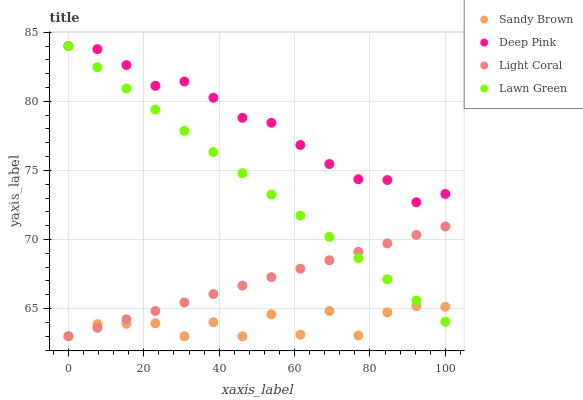Does Sandy Brown have the minimum area under the curve?
Answer yes or no. Yes. Does Deep Pink have the maximum area under the curve?
Answer yes or no. Yes. Does Lawn Green have the minimum area under the curve?
Answer yes or no. No. Does Lawn Green have the maximum area under the curve?
Answer yes or no. No. Is Lawn Green the smoothest?
Answer yes or no. Yes. Is Sandy Brown the roughest?
Answer yes or no. Yes. Is Deep Pink the smoothest?
Answer yes or no. No. Is Deep Pink the roughest?
Answer yes or no. No. Does Light Coral have the lowest value?
Answer yes or no. Yes. Does Lawn Green have the lowest value?
Answer yes or no. No. Does Deep Pink have the highest value?
Answer yes or no. Yes. Does Sandy Brown have the highest value?
Answer yes or no. No. Is Light Coral less than Deep Pink?
Answer yes or no. Yes. Is Deep Pink greater than Light Coral?
Answer yes or no. Yes. Does Lawn Green intersect Sandy Brown?
Answer yes or no. Yes. Is Lawn Green less than Sandy Brown?
Answer yes or no. No. Is Lawn Green greater than Sandy Brown?
Answer yes or no. No. Does Light Coral intersect Deep Pink?
Answer yes or no. No. 